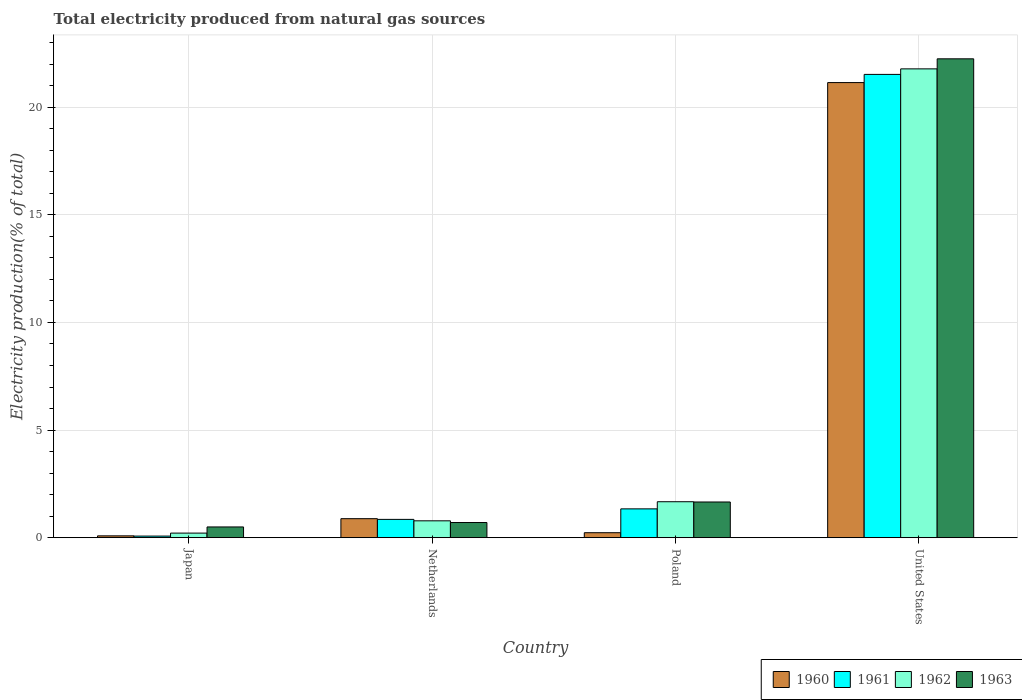How many different coloured bars are there?
Your answer should be very brief. 4. Are the number of bars per tick equal to the number of legend labels?
Your response must be concise. Yes. How many bars are there on the 3rd tick from the right?
Give a very brief answer. 4. What is the label of the 3rd group of bars from the left?
Your answer should be very brief. Poland. In how many cases, is the number of bars for a given country not equal to the number of legend labels?
Offer a very short reply. 0. What is the total electricity produced in 1961 in United States?
Offer a very short reply. 21.52. Across all countries, what is the maximum total electricity produced in 1962?
Provide a succinct answer. 21.78. Across all countries, what is the minimum total electricity produced in 1961?
Provide a short and direct response. 0.08. What is the total total electricity produced in 1962 in the graph?
Provide a short and direct response. 24.45. What is the difference between the total electricity produced in 1962 in Poland and that in United States?
Provide a succinct answer. -20.11. What is the difference between the total electricity produced in 1962 in Netherlands and the total electricity produced in 1963 in United States?
Keep it short and to the point. -21.46. What is the average total electricity produced in 1961 per country?
Give a very brief answer. 5.95. What is the difference between the total electricity produced of/in 1962 and total electricity produced of/in 1963 in Netherlands?
Provide a short and direct response. 0.08. In how many countries, is the total electricity produced in 1963 greater than 12 %?
Ensure brevity in your answer.  1. What is the ratio of the total electricity produced in 1961 in Japan to that in Poland?
Keep it short and to the point. 0.06. What is the difference between the highest and the second highest total electricity produced in 1962?
Your answer should be compact. -0.89. What is the difference between the highest and the lowest total electricity produced in 1963?
Offer a very short reply. 21.74. What does the 2nd bar from the left in Japan represents?
Your response must be concise. 1961. What does the 2nd bar from the right in Netherlands represents?
Ensure brevity in your answer.  1962. How many bars are there?
Keep it short and to the point. 16. What is the difference between two consecutive major ticks on the Y-axis?
Ensure brevity in your answer.  5. Are the values on the major ticks of Y-axis written in scientific E-notation?
Offer a terse response. No. Does the graph contain any zero values?
Ensure brevity in your answer.  No. Does the graph contain grids?
Keep it short and to the point. Yes. How many legend labels are there?
Your answer should be very brief. 4. How are the legend labels stacked?
Your answer should be compact. Horizontal. What is the title of the graph?
Make the answer very short. Total electricity produced from natural gas sources. Does "1986" appear as one of the legend labels in the graph?
Make the answer very short. No. What is the label or title of the X-axis?
Your answer should be compact. Country. What is the label or title of the Y-axis?
Offer a terse response. Electricity production(% of total). What is the Electricity production(% of total) of 1960 in Japan?
Offer a very short reply. 0.09. What is the Electricity production(% of total) of 1961 in Japan?
Ensure brevity in your answer.  0.08. What is the Electricity production(% of total) in 1962 in Japan?
Your answer should be compact. 0.21. What is the Electricity production(% of total) in 1963 in Japan?
Ensure brevity in your answer.  0.5. What is the Electricity production(% of total) of 1960 in Netherlands?
Give a very brief answer. 0.88. What is the Electricity production(% of total) in 1961 in Netherlands?
Ensure brevity in your answer.  0.85. What is the Electricity production(% of total) of 1962 in Netherlands?
Your answer should be very brief. 0.78. What is the Electricity production(% of total) of 1963 in Netherlands?
Your answer should be very brief. 0.71. What is the Electricity production(% of total) in 1960 in Poland?
Give a very brief answer. 0.23. What is the Electricity production(% of total) of 1961 in Poland?
Give a very brief answer. 1.34. What is the Electricity production(% of total) in 1962 in Poland?
Provide a succinct answer. 1.67. What is the Electricity production(% of total) in 1963 in Poland?
Your response must be concise. 1.66. What is the Electricity production(% of total) of 1960 in United States?
Provide a succinct answer. 21.14. What is the Electricity production(% of total) of 1961 in United States?
Make the answer very short. 21.52. What is the Electricity production(% of total) in 1962 in United States?
Provide a succinct answer. 21.78. What is the Electricity production(% of total) of 1963 in United States?
Give a very brief answer. 22.24. Across all countries, what is the maximum Electricity production(% of total) in 1960?
Your response must be concise. 21.14. Across all countries, what is the maximum Electricity production(% of total) in 1961?
Offer a very short reply. 21.52. Across all countries, what is the maximum Electricity production(% of total) of 1962?
Give a very brief answer. 21.78. Across all countries, what is the maximum Electricity production(% of total) of 1963?
Offer a very short reply. 22.24. Across all countries, what is the minimum Electricity production(% of total) of 1960?
Ensure brevity in your answer.  0.09. Across all countries, what is the minimum Electricity production(% of total) of 1961?
Your response must be concise. 0.08. Across all countries, what is the minimum Electricity production(% of total) of 1962?
Offer a terse response. 0.21. Across all countries, what is the minimum Electricity production(% of total) in 1963?
Your answer should be very brief. 0.5. What is the total Electricity production(% of total) of 1960 in the graph?
Offer a very short reply. 22.34. What is the total Electricity production(% of total) in 1961 in the graph?
Offer a very short reply. 23.79. What is the total Electricity production(% of total) in 1962 in the graph?
Your answer should be compact. 24.45. What is the total Electricity production(% of total) of 1963 in the graph?
Keep it short and to the point. 25.11. What is the difference between the Electricity production(% of total) in 1960 in Japan and that in Netherlands?
Keep it short and to the point. -0.8. What is the difference between the Electricity production(% of total) in 1961 in Japan and that in Netherlands?
Keep it short and to the point. -0.78. What is the difference between the Electricity production(% of total) in 1962 in Japan and that in Netherlands?
Provide a succinct answer. -0.57. What is the difference between the Electricity production(% of total) of 1963 in Japan and that in Netherlands?
Provide a succinct answer. -0.21. What is the difference between the Electricity production(% of total) in 1960 in Japan and that in Poland?
Your answer should be compact. -0.15. What is the difference between the Electricity production(% of total) of 1961 in Japan and that in Poland?
Your answer should be very brief. -1.26. What is the difference between the Electricity production(% of total) of 1962 in Japan and that in Poland?
Make the answer very short. -1.46. What is the difference between the Electricity production(% of total) of 1963 in Japan and that in Poland?
Your answer should be very brief. -1.16. What is the difference between the Electricity production(% of total) of 1960 in Japan and that in United States?
Your answer should be compact. -21.05. What is the difference between the Electricity production(% of total) in 1961 in Japan and that in United States?
Offer a very short reply. -21.45. What is the difference between the Electricity production(% of total) of 1962 in Japan and that in United States?
Ensure brevity in your answer.  -21.56. What is the difference between the Electricity production(% of total) of 1963 in Japan and that in United States?
Ensure brevity in your answer.  -21.74. What is the difference between the Electricity production(% of total) of 1960 in Netherlands and that in Poland?
Your response must be concise. 0.65. What is the difference between the Electricity production(% of total) of 1961 in Netherlands and that in Poland?
Make the answer very short. -0.49. What is the difference between the Electricity production(% of total) in 1962 in Netherlands and that in Poland?
Ensure brevity in your answer.  -0.89. What is the difference between the Electricity production(% of total) of 1963 in Netherlands and that in Poland?
Ensure brevity in your answer.  -0.95. What is the difference between the Electricity production(% of total) of 1960 in Netherlands and that in United States?
Offer a very short reply. -20.26. What is the difference between the Electricity production(% of total) in 1961 in Netherlands and that in United States?
Ensure brevity in your answer.  -20.67. What is the difference between the Electricity production(% of total) of 1962 in Netherlands and that in United States?
Your answer should be compact. -20.99. What is the difference between the Electricity production(% of total) of 1963 in Netherlands and that in United States?
Provide a succinct answer. -21.54. What is the difference between the Electricity production(% of total) of 1960 in Poland and that in United States?
Your answer should be very brief. -20.91. What is the difference between the Electricity production(% of total) of 1961 in Poland and that in United States?
Your answer should be very brief. -20.18. What is the difference between the Electricity production(% of total) of 1962 in Poland and that in United States?
Provide a succinct answer. -20.11. What is the difference between the Electricity production(% of total) of 1963 in Poland and that in United States?
Your response must be concise. -20.59. What is the difference between the Electricity production(% of total) of 1960 in Japan and the Electricity production(% of total) of 1961 in Netherlands?
Provide a succinct answer. -0.76. What is the difference between the Electricity production(% of total) of 1960 in Japan and the Electricity production(% of total) of 1962 in Netherlands?
Give a very brief answer. -0.7. What is the difference between the Electricity production(% of total) in 1960 in Japan and the Electricity production(% of total) in 1963 in Netherlands?
Offer a very short reply. -0.62. What is the difference between the Electricity production(% of total) of 1961 in Japan and the Electricity production(% of total) of 1962 in Netherlands?
Offer a very short reply. -0.71. What is the difference between the Electricity production(% of total) of 1961 in Japan and the Electricity production(% of total) of 1963 in Netherlands?
Give a very brief answer. -0.63. What is the difference between the Electricity production(% of total) in 1962 in Japan and the Electricity production(% of total) in 1963 in Netherlands?
Offer a terse response. -0.49. What is the difference between the Electricity production(% of total) of 1960 in Japan and the Electricity production(% of total) of 1961 in Poland?
Provide a short and direct response. -1.25. What is the difference between the Electricity production(% of total) in 1960 in Japan and the Electricity production(% of total) in 1962 in Poland?
Give a very brief answer. -1.58. What is the difference between the Electricity production(% of total) in 1960 in Japan and the Electricity production(% of total) in 1963 in Poland?
Ensure brevity in your answer.  -1.57. What is the difference between the Electricity production(% of total) in 1961 in Japan and the Electricity production(% of total) in 1962 in Poland?
Make the answer very short. -1.6. What is the difference between the Electricity production(% of total) of 1961 in Japan and the Electricity production(% of total) of 1963 in Poland?
Your answer should be very brief. -1.58. What is the difference between the Electricity production(% of total) in 1962 in Japan and the Electricity production(% of total) in 1963 in Poland?
Your answer should be very brief. -1.45. What is the difference between the Electricity production(% of total) of 1960 in Japan and the Electricity production(% of total) of 1961 in United States?
Provide a short and direct response. -21.43. What is the difference between the Electricity production(% of total) in 1960 in Japan and the Electricity production(% of total) in 1962 in United States?
Your answer should be compact. -21.69. What is the difference between the Electricity production(% of total) in 1960 in Japan and the Electricity production(% of total) in 1963 in United States?
Offer a very short reply. -22.16. What is the difference between the Electricity production(% of total) of 1961 in Japan and the Electricity production(% of total) of 1962 in United States?
Your response must be concise. -21.7. What is the difference between the Electricity production(% of total) in 1961 in Japan and the Electricity production(% of total) in 1963 in United States?
Offer a very short reply. -22.17. What is the difference between the Electricity production(% of total) in 1962 in Japan and the Electricity production(% of total) in 1963 in United States?
Offer a very short reply. -22.03. What is the difference between the Electricity production(% of total) in 1960 in Netherlands and the Electricity production(% of total) in 1961 in Poland?
Your answer should be compact. -0.46. What is the difference between the Electricity production(% of total) of 1960 in Netherlands and the Electricity production(% of total) of 1962 in Poland?
Your response must be concise. -0.79. What is the difference between the Electricity production(% of total) of 1960 in Netherlands and the Electricity production(% of total) of 1963 in Poland?
Give a very brief answer. -0.78. What is the difference between the Electricity production(% of total) in 1961 in Netherlands and the Electricity production(% of total) in 1962 in Poland?
Give a very brief answer. -0.82. What is the difference between the Electricity production(% of total) in 1961 in Netherlands and the Electricity production(% of total) in 1963 in Poland?
Give a very brief answer. -0.81. What is the difference between the Electricity production(% of total) in 1962 in Netherlands and the Electricity production(% of total) in 1963 in Poland?
Offer a terse response. -0.88. What is the difference between the Electricity production(% of total) in 1960 in Netherlands and the Electricity production(% of total) in 1961 in United States?
Provide a short and direct response. -20.64. What is the difference between the Electricity production(% of total) in 1960 in Netherlands and the Electricity production(% of total) in 1962 in United States?
Your answer should be compact. -20.89. What is the difference between the Electricity production(% of total) in 1960 in Netherlands and the Electricity production(% of total) in 1963 in United States?
Your answer should be compact. -21.36. What is the difference between the Electricity production(% of total) of 1961 in Netherlands and the Electricity production(% of total) of 1962 in United States?
Provide a short and direct response. -20.93. What is the difference between the Electricity production(% of total) in 1961 in Netherlands and the Electricity production(% of total) in 1963 in United States?
Keep it short and to the point. -21.39. What is the difference between the Electricity production(% of total) of 1962 in Netherlands and the Electricity production(% of total) of 1963 in United States?
Your response must be concise. -21.46. What is the difference between the Electricity production(% of total) of 1960 in Poland and the Electricity production(% of total) of 1961 in United States?
Your answer should be compact. -21.29. What is the difference between the Electricity production(% of total) of 1960 in Poland and the Electricity production(% of total) of 1962 in United States?
Ensure brevity in your answer.  -21.55. What is the difference between the Electricity production(% of total) of 1960 in Poland and the Electricity production(% of total) of 1963 in United States?
Keep it short and to the point. -22.01. What is the difference between the Electricity production(% of total) in 1961 in Poland and the Electricity production(% of total) in 1962 in United States?
Keep it short and to the point. -20.44. What is the difference between the Electricity production(% of total) of 1961 in Poland and the Electricity production(% of total) of 1963 in United States?
Offer a terse response. -20.91. What is the difference between the Electricity production(% of total) in 1962 in Poland and the Electricity production(% of total) in 1963 in United States?
Offer a very short reply. -20.57. What is the average Electricity production(% of total) in 1960 per country?
Offer a very short reply. 5.59. What is the average Electricity production(% of total) of 1961 per country?
Offer a terse response. 5.95. What is the average Electricity production(% of total) in 1962 per country?
Offer a very short reply. 6.11. What is the average Electricity production(% of total) in 1963 per country?
Give a very brief answer. 6.28. What is the difference between the Electricity production(% of total) of 1960 and Electricity production(% of total) of 1961 in Japan?
Your answer should be very brief. 0.01. What is the difference between the Electricity production(% of total) of 1960 and Electricity production(% of total) of 1962 in Japan?
Give a very brief answer. -0.13. What is the difference between the Electricity production(% of total) of 1960 and Electricity production(% of total) of 1963 in Japan?
Offer a terse response. -0.41. What is the difference between the Electricity production(% of total) of 1961 and Electricity production(% of total) of 1962 in Japan?
Give a very brief answer. -0.14. What is the difference between the Electricity production(% of total) of 1961 and Electricity production(% of total) of 1963 in Japan?
Offer a very short reply. -0.42. What is the difference between the Electricity production(% of total) in 1962 and Electricity production(% of total) in 1963 in Japan?
Make the answer very short. -0.29. What is the difference between the Electricity production(% of total) in 1960 and Electricity production(% of total) in 1961 in Netherlands?
Ensure brevity in your answer.  0.03. What is the difference between the Electricity production(% of total) of 1960 and Electricity production(% of total) of 1962 in Netherlands?
Your answer should be compact. 0.1. What is the difference between the Electricity production(% of total) of 1960 and Electricity production(% of total) of 1963 in Netherlands?
Provide a short and direct response. 0.18. What is the difference between the Electricity production(% of total) in 1961 and Electricity production(% of total) in 1962 in Netherlands?
Provide a succinct answer. 0.07. What is the difference between the Electricity production(% of total) in 1961 and Electricity production(% of total) in 1963 in Netherlands?
Offer a very short reply. 0.15. What is the difference between the Electricity production(% of total) of 1962 and Electricity production(% of total) of 1963 in Netherlands?
Give a very brief answer. 0.08. What is the difference between the Electricity production(% of total) of 1960 and Electricity production(% of total) of 1961 in Poland?
Your answer should be compact. -1.11. What is the difference between the Electricity production(% of total) of 1960 and Electricity production(% of total) of 1962 in Poland?
Your response must be concise. -1.44. What is the difference between the Electricity production(% of total) of 1960 and Electricity production(% of total) of 1963 in Poland?
Your answer should be compact. -1.43. What is the difference between the Electricity production(% of total) of 1961 and Electricity production(% of total) of 1962 in Poland?
Offer a very short reply. -0.33. What is the difference between the Electricity production(% of total) in 1961 and Electricity production(% of total) in 1963 in Poland?
Offer a very short reply. -0.32. What is the difference between the Electricity production(% of total) in 1962 and Electricity production(% of total) in 1963 in Poland?
Your response must be concise. 0.01. What is the difference between the Electricity production(% of total) in 1960 and Electricity production(% of total) in 1961 in United States?
Give a very brief answer. -0.38. What is the difference between the Electricity production(% of total) in 1960 and Electricity production(% of total) in 1962 in United States?
Ensure brevity in your answer.  -0.64. What is the difference between the Electricity production(% of total) in 1960 and Electricity production(% of total) in 1963 in United States?
Offer a terse response. -1.1. What is the difference between the Electricity production(% of total) in 1961 and Electricity production(% of total) in 1962 in United States?
Keep it short and to the point. -0.26. What is the difference between the Electricity production(% of total) in 1961 and Electricity production(% of total) in 1963 in United States?
Your response must be concise. -0.72. What is the difference between the Electricity production(% of total) of 1962 and Electricity production(% of total) of 1963 in United States?
Offer a terse response. -0.47. What is the ratio of the Electricity production(% of total) in 1960 in Japan to that in Netherlands?
Your answer should be compact. 0.1. What is the ratio of the Electricity production(% of total) of 1961 in Japan to that in Netherlands?
Your response must be concise. 0.09. What is the ratio of the Electricity production(% of total) of 1962 in Japan to that in Netherlands?
Make the answer very short. 0.27. What is the ratio of the Electricity production(% of total) of 1963 in Japan to that in Netherlands?
Make the answer very short. 0.71. What is the ratio of the Electricity production(% of total) in 1960 in Japan to that in Poland?
Provide a short and direct response. 0.37. What is the ratio of the Electricity production(% of total) in 1961 in Japan to that in Poland?
Make the answer very short. 0.06. What is the ratio of the Electricity production(% of total) of 1962 in Japan to that in Poland?
Your answer should be compact. 0.13. What is the ratio of the Electricity production(% of total) in 1963 in Japan to that in Poland?
Offer a terse response. 0.3. What is the ratio of the Electricity production(% of total) in 1960 in Japan to that in United States?
Ensure brevity in your answer.  0. What is the ratio of the Electricity production(% of total) of 1961 in Japan to that in United States?
Offer a terse response. 0. What is the ratio of the Electricity production(% of total) in 1962 in Japan to that in United States?
Your response must be concise. 0.01. What is the ratio of the Electricity production(% of total) in 1963 in Japan to that in United States?
Ensure brevity in your answer.  0.02. What is the ratio of the Electricity production(% of total) in 1960 in Netherlands to that in Poland?
Your answer should be compact. 3.81. What is the ratio of the Electricity production(% of total) in 1961 in Netherlands to that in Poland?
Offer a terse response. 0.64. What is the ratio of the Electricity production(% of total) of 1962 in Netherlands to that in Poland?
Keep it short and to the point. 0.47. What is the ratio of the Electricity production(% of total) in 1963 in Netherlands to that in Poland?
Ensure brevity in your answer.  0.42. What is the ratio of the Electricity production(% of total) of 1960 in Netherlands to that in United States?
Your response must be concise. 0.04. What is the ratio of the Electricity production(% of total) in 1961 in Netherlands to that in United States?
Your answer should be compact. 0.04. What is the ratio of the Electricity production(% of total) of 1962 in Netherlands to that in United States?
Ensure brevity in your answer.  0.04. What is the ratio of the Electricity production(% of total) of 1963 in Netherlands to that in United States?
Make the answer very short. 0.03. What is the ratio of the Electricity production(% of total) in 1960 in Poland to that in United States?
Keep it short and to the point. 0.01. What is the ratio of the Electricity production(% of total) of 1961 in Poland to that in United States?
Keep it short and to the point. 0.06. What is the ratio of the Electricity production(% of total) of 1962 in Poland to that in United States?
Make the answer very short. 0.08. What is the ratio of the Electricity production(% of total) of 1963 in Poland to that in United States?
Make the answer very short. 0.07. What is the difference between the highest and the second highest Electricity production(% of total) of 1960?
Provide a succinct answer. 20.26. What is the difference between the highest and the second highest Electricity production(% of total) of 1961?
Ensure brevity in your answer.  20.18. What is the difference between the highest and the second highest Electricity production(% of total) in 1962?
Your answer should be compact. 20.11. What is the difference between the highest and the second highest Electricity production(% of total) of 1963?
Ensure brevity in your answer.  20.59. What is the difference between the highest and the lowest Electricity production(% of total) in 1960?
Keep it short and to the point. 21.05. What is the difference between the highest and the lowest Electricity production(% of total) in 1961?
Offer a very short reply. 21.45. What is the difference between the highest and the lowest Electricity production(% of total) of 1962?
Give a very brief answer. 21.56. What is the difference between the highest and the lowest Electricity production(% of total) of 1963?
Your answer should be very brief. 21.74. 